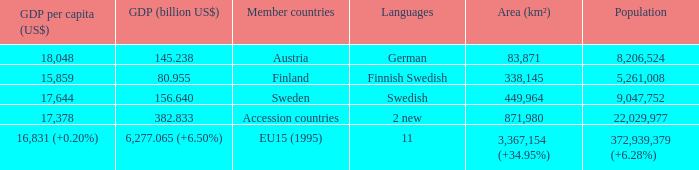Name the area for german 83871.0. 